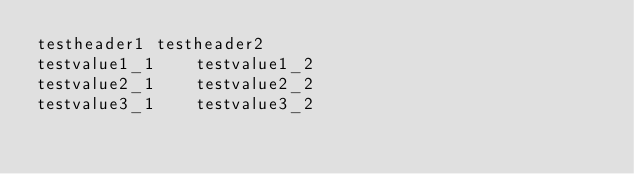Convert code to text. <code><loc_0><loc_0><loc_500><loc_500><_SQL_>testheader1	testheader2
testvalue1_1	testvalue1_2
testvalue2_1	testvalue2_2
testvalue3_1	testvalue3_2
</code> 